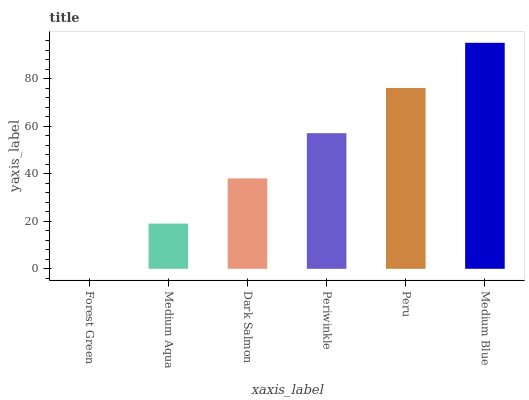Is Forest Green the minimum?
Answer yes or no. Yes. Is Medium Blue the maximum?
Answer yes or no. Yes. Is Medium Aqua the minimum?
Answer yes or no. No. Is Medium Aqua the maximum?
Answer yes or no. No. Is Medium Aqua greater than Forest Green?
Answer yes or no. Yes. Is Forest Green less than Medium Aqua?
Answer yes or no. Yes. Is Forest Green greater than Medium Aqua?
Answer yes or no. No. Is Medium Aqua less than Forest Green?
Answer yes or no. No. Is Periwinkle the high median?
Answer yes or no. Yes. Is Dark Salmon the low median?
Answer yes or no. Yes. Is Peru the high median?
Answer yes or no. No. Is Periwinkle the low median?
Answer yes or no. No. 